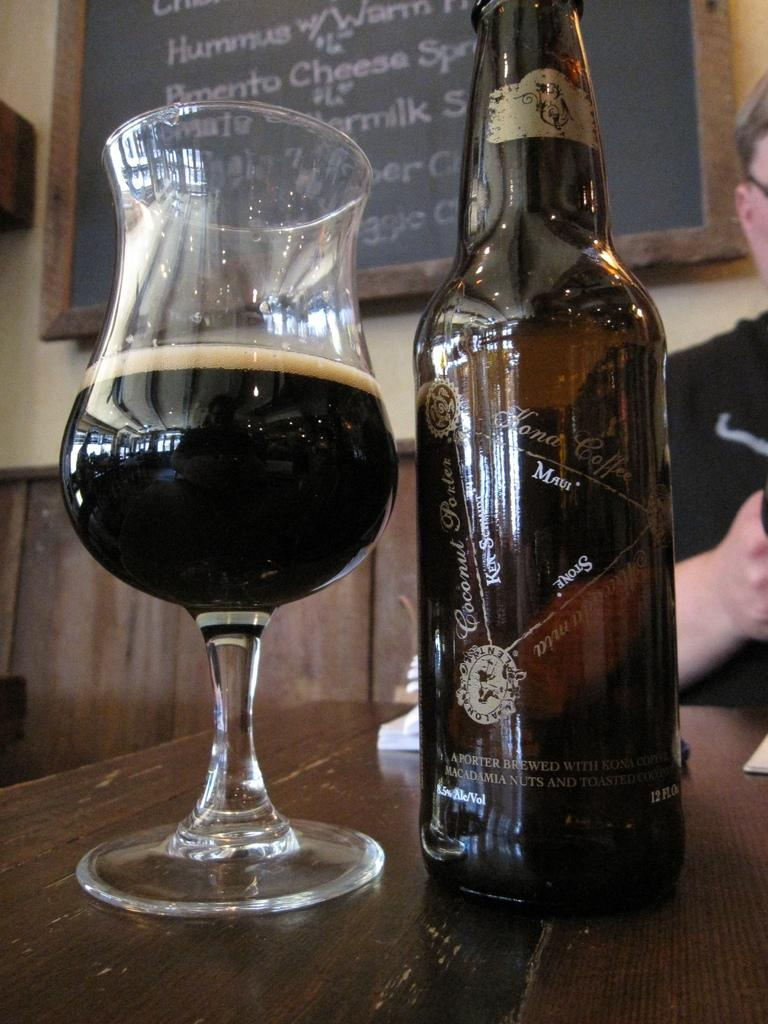What is in the glass that is visible in the image? There is a glass of wine in the image. What is the source of the wine in the glass? There is a wine bottle in the image. Where are the glass of wine and wine bottle located? They are on a table in the image. Who is present in the image? There is a man in the image. What can be seen in the background of the image? There is a wall and a board in the image. What type of fowl can be seen walking on the hill in the image? There is no fowl or hill present in the image. How many pairs of shoes are visible in the image? There is no mention of shoes in the image. 